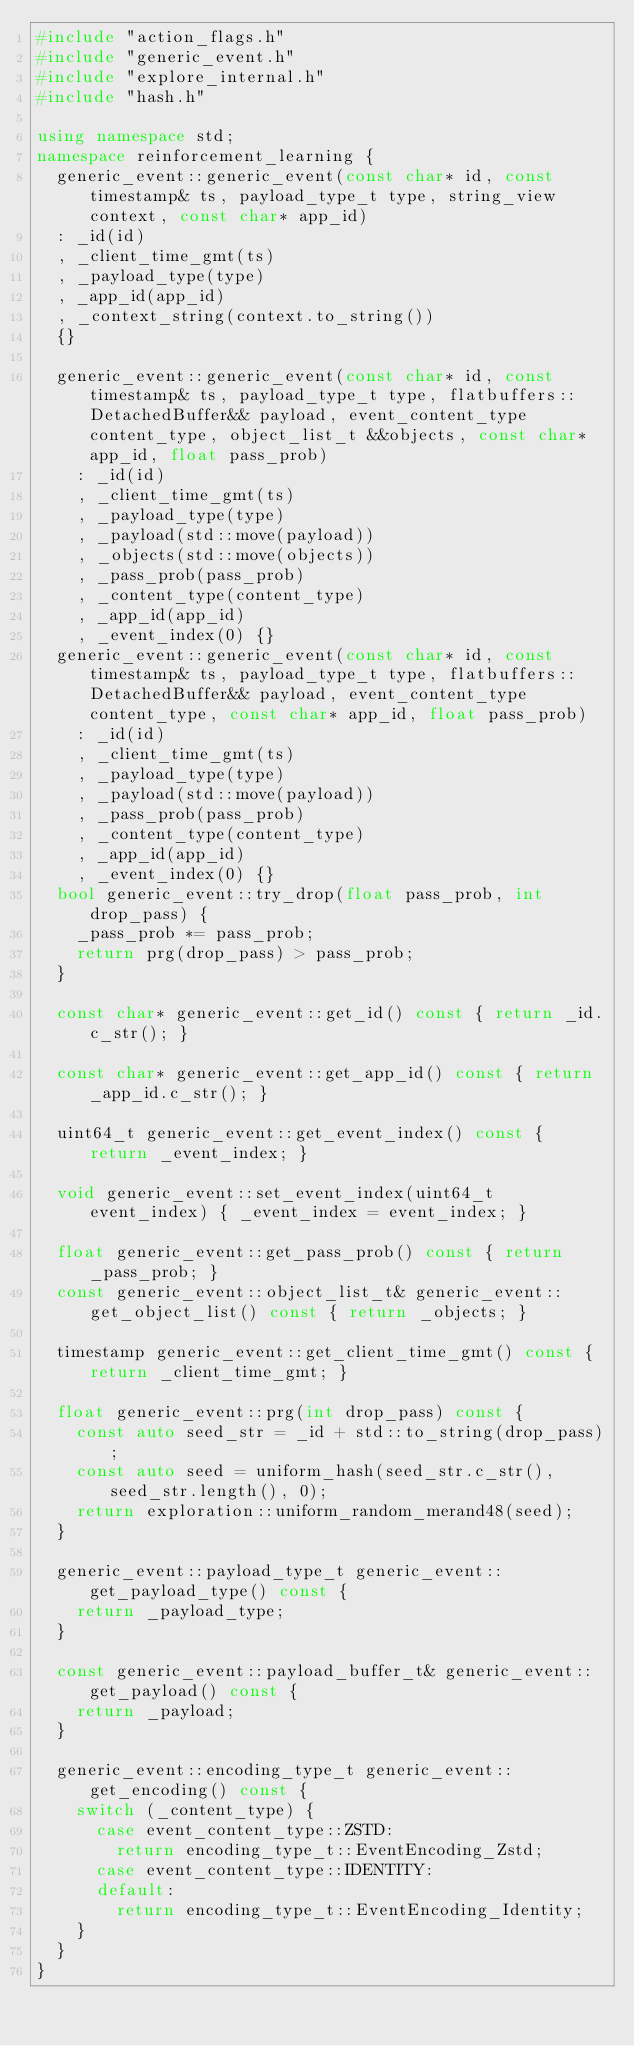Convert code to text. <code><loc_0><loc_0><loc_500><loc_500><_C++_>#include "action_flags.h"
#include "generic_event.h"
#include "explore_internal.h"
#include "hash.h"

using namespace std;
namespace reinforcement_learning {
  generic_event::generic_event(const char* id, const timestamp& ts, payload_type_t type, string_view context, const char* app_id)
  : _id(id)
  , _client_time_gmt(ts)
  , _payload_type(type)
  , _app_id(app_id)
  , _context_string(context.to_string())
  {}

  generic_event::generic_event(const char* id, const timestamp& ts, payload_type_t type, flatbuffers::DetachedBuffer&& payload, event_content_type content_type, object_list_t &&objects, const char* app_id, float pass_prob)
    : _id(id)
    , _client_time_gmt(ts)
    , _payload_type(type)
    , _payload(std::move(payload))
    , _objects(std::move(objects))
    , _pass_prob(pass_prob)
    , _content_type(content_type) 
    , _app_id(app_id) 
    , _event_index(0) {}
  generic_event::generic_event(const char* id, const timestamp& ts, payload_type_t type, flatbuffers::DetachedBuffer&& payload, event_content_type content_type, const char* app_id, float pass_prob)
    : _id(id)
    , _client_time_gmt(ts)
    , _payload_type(type)
    , _payload(std::move(payload))
    , _pass_prob(pass_prob)
    , _content_type(content_type) 
    , _app_id(app_id)
    , _event_index(0) {}
  bool generic_event::try_drop(float pass_prob, int drop_pass) {
    _pass_prob *= pass_prob;
    return prg(drop_pass) > pass_prob;
  }

  const char* generic_event::get_id() const { return _id.c_str(); }

  const char* generic_event::get_app_id() const { return _app_id.c_str(); }  

  uint64_t generic_event::get_event_index() const { return _event_index; }

  void generic_event::set_event_index(uint64_t event_index) { _event_index = event_index; }

  float generic_event::get_pass_prob() const { return _pass_prob; }
  const generic_event::object_list_t& generic_event::get_object_list() const { return _objects; }

  timestamp generic_event::get_client_time_gmt() const { return _client_time_gmt; }

  float generic_event::prg(int drop_pass) const {
    const auto seed_str = _id + std::to_string(drop_pass);
    const auto seed = uniform_hash(seed_str.c_str(), seed_str.length(), 0);
    return exploration::uniform_random_merand48(seed);
  }

  generic_event::payload_type_t generic_event::get_payload_type() const {
    return _payload_type;
  }

  const generic_event::payload_buffer_t& generic_event::get_payload() const {
    return _payload;
  }

  generic_event::encoding_type_t generic_event::get_encoding() const {
    switch (_content_type) {
      case event_content_type::ZSTD:
        return encoding_type_t::EventEncoding_Zstd;
      case event_content_type::IDENTITY:
      default:
        return encoding_type_t::EventEncoding_Identity;
    }
  }
}
</code> 